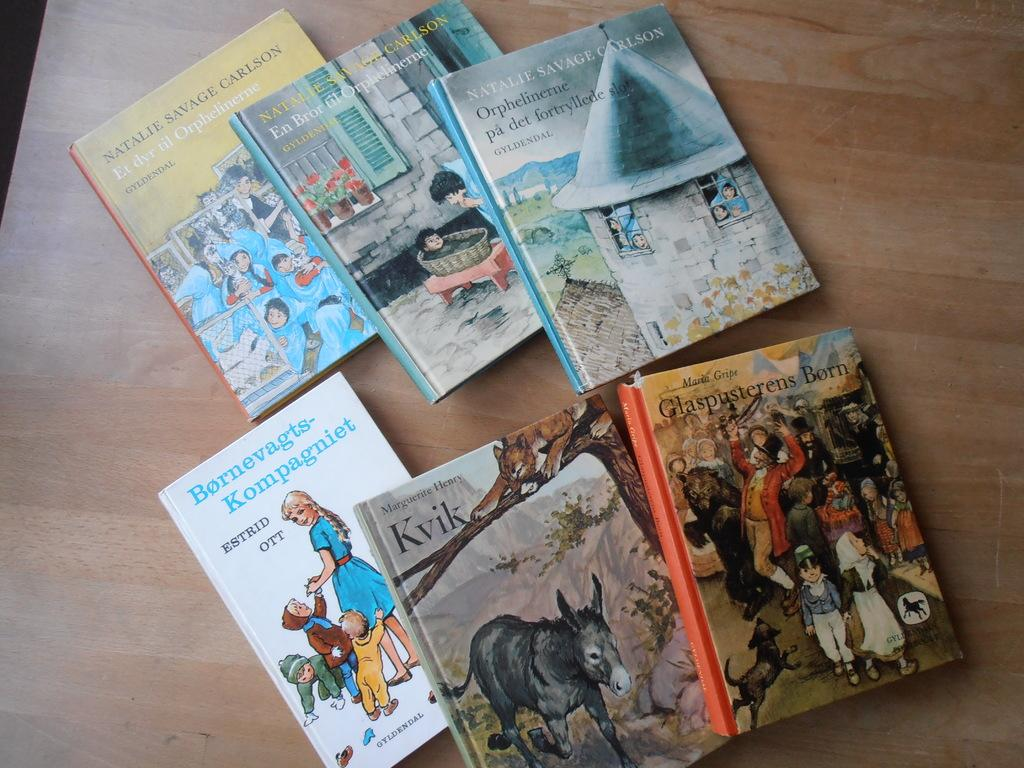<image>
Share a concise interpretation of the image provided. the word Kvik that is on a book 